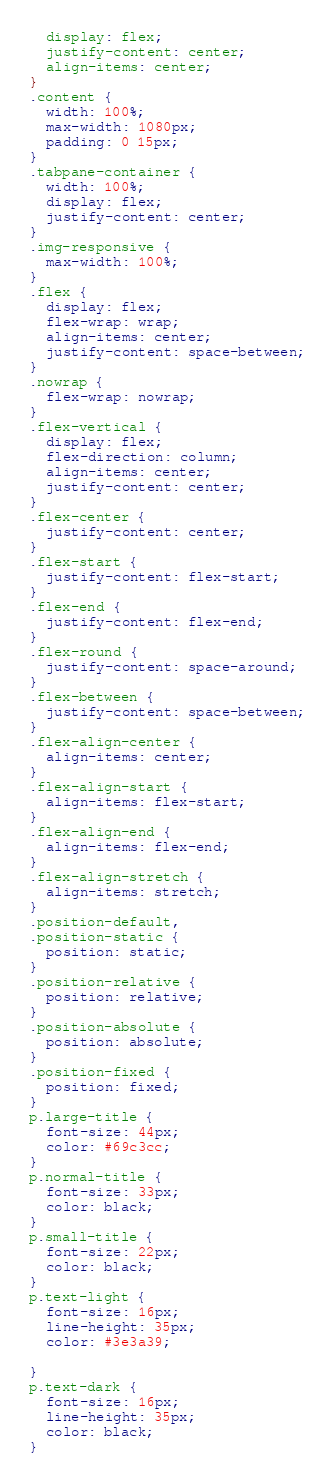Convert code to text. <code><loc_0><loc_0><loc_500><loc_500><_CSS_>  display: flex;
  justify-content: center;
  align-items: center;
}
.content {
  width: 100%;
  max-width: 1080px;
  padding: 0 15px;
}
.tabpane-container {
  width: 100%;
  display: flex;
  justify-content: center;
}
.img-responsive {
  max-width: 100%;
}
.flex {
  display: flex;
  flex-wrap: wrap;
  align-items: center;
  justify-content: space-between;
}
.nowrap {
  flex-wrap: nowrap;
}
.flex-vertical {
  display: flex;
  flex-direction: column;
  align-items: center;
  justify-content: center;
}
.flex-center {
  justify-content: center;
}
.flex-start {
  justify-content: flex-start;
}
.flex-end {
  justify-content: flex-end;
}
.flex-round {
  justify-content: space-around;
}
.flex-between {
  justify-content: space-between;
}
.flex-align-center {
  align-items: center;
}
.flex-align-start {
  align-items: flex-start;
}
.flex-align-end {
  align-items: flex-end;
}
.flex-align-stretch {
  align-items: stretch;
}
.position-default,
.position-static {
  position: static;
}
.position-relative {
  position: relative;
}
.position-absolute {
  position: absolute;
}
.position-fixed {
  position: fixed;
}
p.large-title {
  font-size: 44px;
  color: #69c3cc;
}
p.normal-title {
  font-size: 33px;
  color: black;
}
p.small-title {
  font-size: 22px;
  color: black;
}
p.text-light {
  font-size: 16px;
  line-height: 35px;
  color: #3e3a39;

}
p.text-dark {
  font-size: 16px;
  line-height: 35px;
  color: black;
}
</code> 